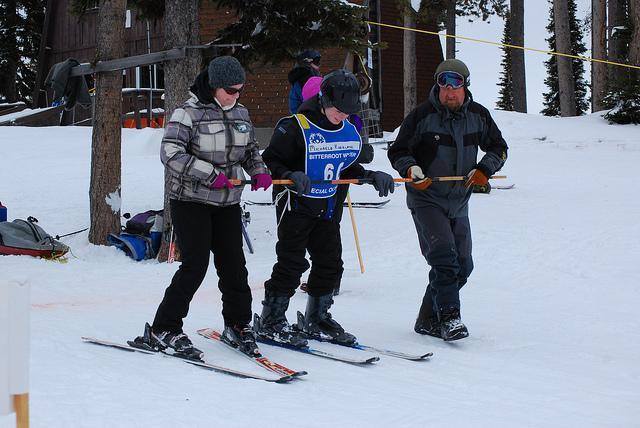How many people are there?
Give a very brief answer. 3. How many buses are there?
Give a very brief answer. 0. 